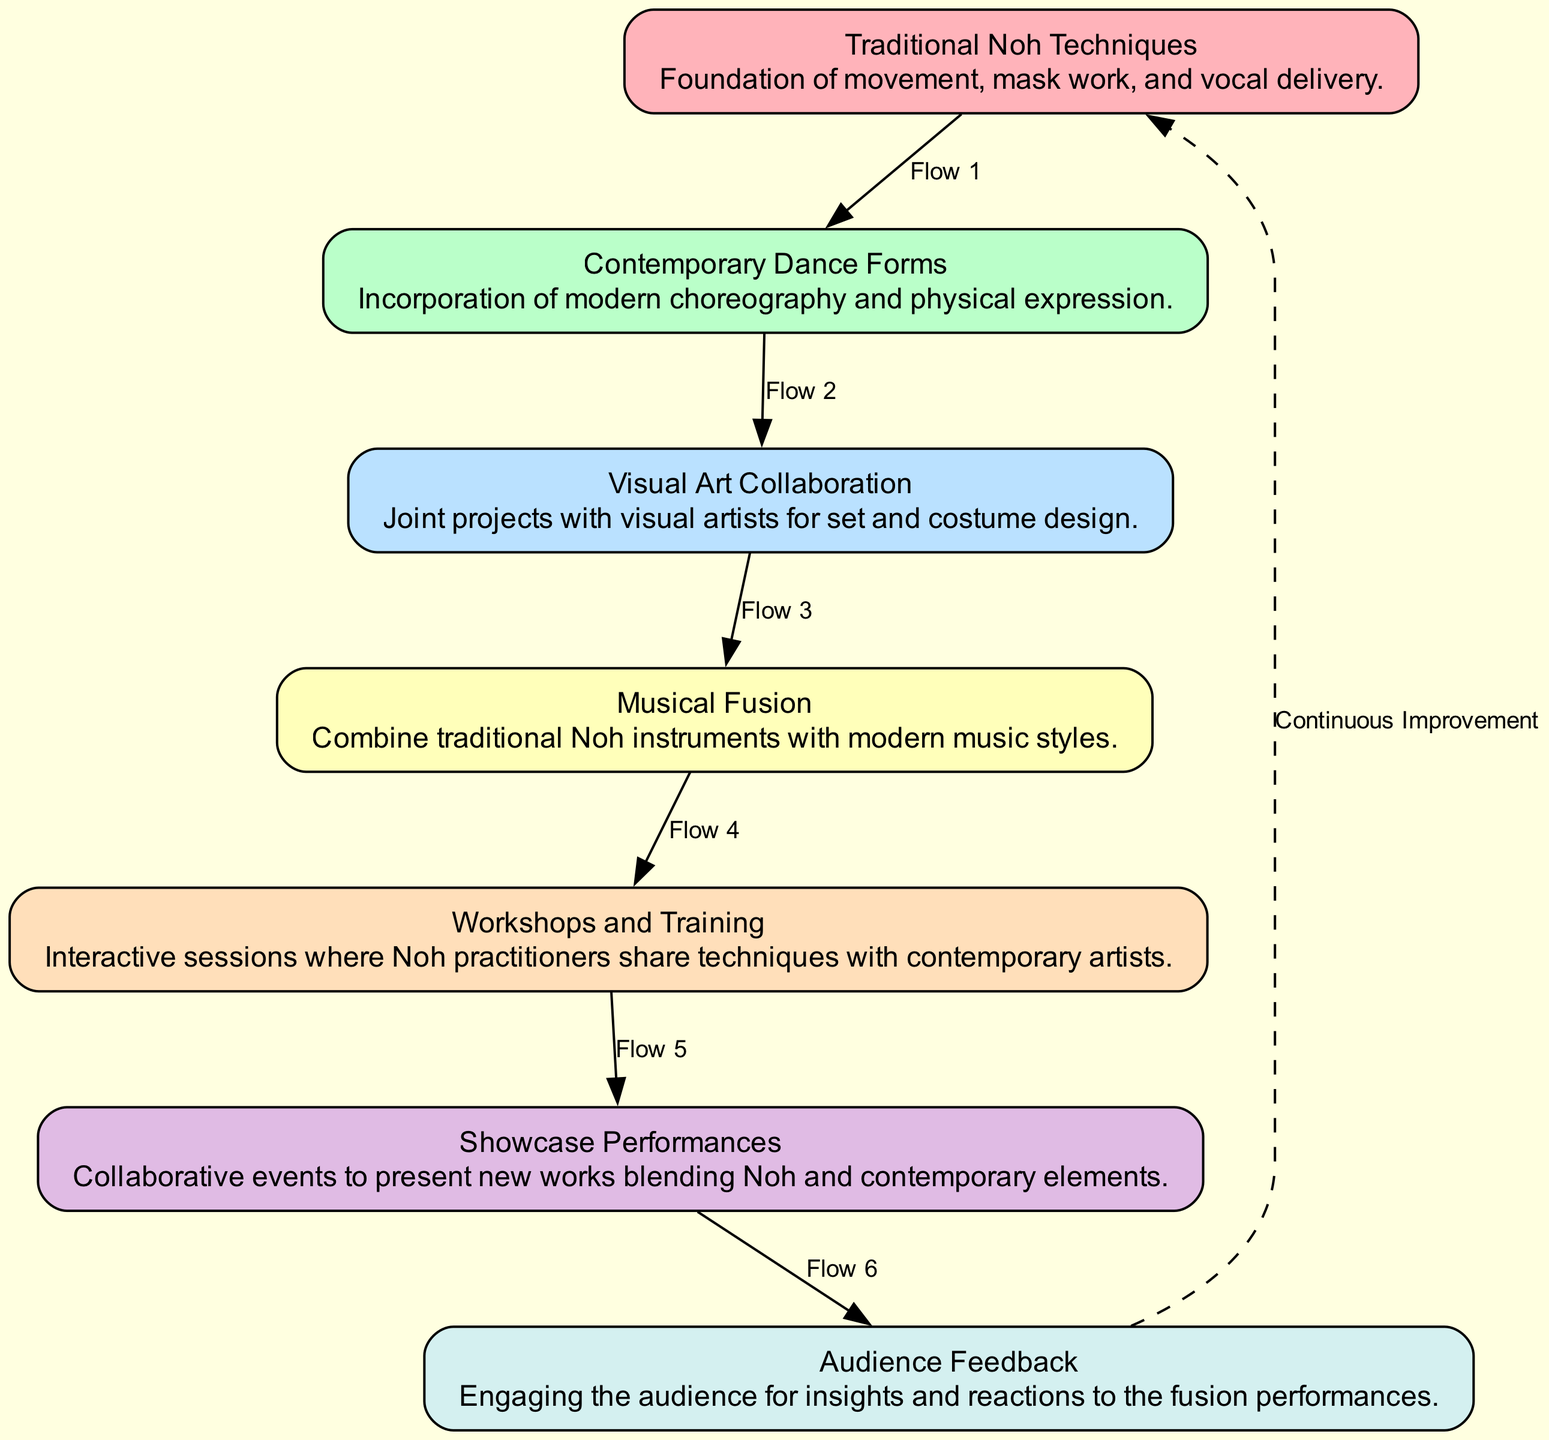What is the first element in the flow chart? The first element in the flow chart is "Traditional Noh Techniques" as it is the starting point designated in the flow.
Answer: Traditional Noh Techniques How many nodes are present in the diagram? The diagram consists of a total of 7 nodes representing different aspects of the collaborative creation process.
Answer: 7 What connects "Musical Fusion" to the next element? "Musical Fusion" is connected to "Workshops and Training" via a directed edge illustrating the flow of ideas.
Answer: Workshops and Training Which element is described as "Collaborative events to present new works blending Noh and contemporary elements"? This description corresponds to the element "Showcase Performances" as it specifically mentions showcasing the fusion of Noh and contemporary arts.
Answer: Showcase Performances What is the final element before the flow loops back to the first? The last element before the flow returns to the first element is "Audience Feedback" as indicated by the sequential arrangement of nodes leading back to the beginning.
Answer: Audience Feedback Which two elements are directly connected before reaching "Showcase Performances"? The two elements that are directly connected before "Showcase Performances" are "Workshops and Training" and "Showcase Performances" itself.
Answer: Workshops and Training, Showcase Performances What type of relationship is represented by the dashed edge returning to the first node? The dashed edge illustrates a relationship of "Continuous Improvement", indicating a feedback loop in the collaborative process.
Answer: Continuous Improvement 